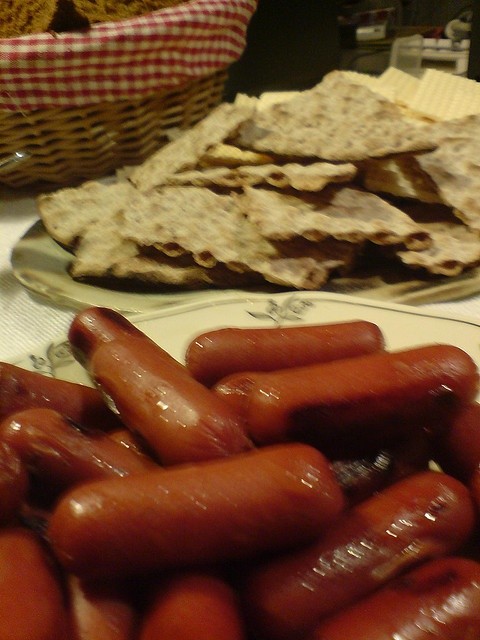Describe the objects in this image and their specific colors. I can see hot dog in maroon, black, and brown tones, hot dog in maroon tones, hot dog in maroon, black, and brown tones, hot dog in maroon, brown, and tan tones, and hot dog in maroon, brown, and gray tones in this image. 